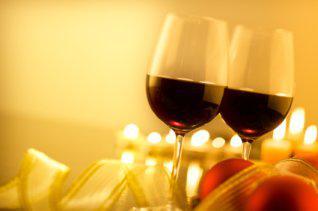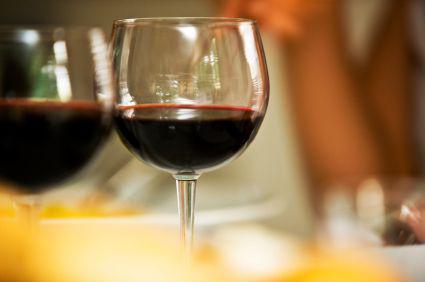The first image is the image on the left, the second image is the image on the right. Examine the images to the left and right. Is the description "The right image has two wine glasses with a bottle of wine to the left of them." accurate? Answer yes or no. No. The first image is the image on the left, the second image is the image on the right. Examine the images to the left and right. Is the description "There are two half filled wine glasses next to the bottle in the right image." accurate? Answer yes or no. No. 